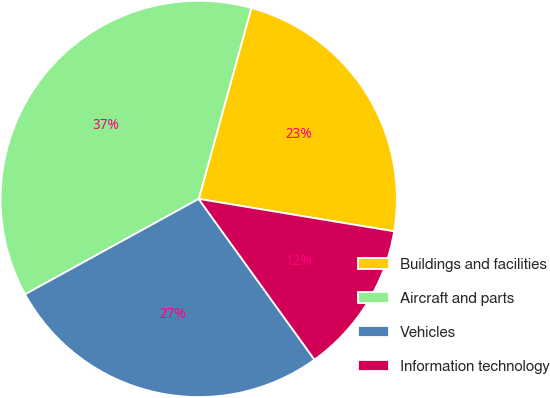Convert chart. <chart><loc_0><loc_0><loc_500><loc_500><pie_chart><fcel>Buildings and facilities<fcel>Aircraft and parts<fcel>Vehicles<fcel>Information technology<nl><fcel>23.34%<fcel>37.28%<fcel>26.94%<fcel>12.45%<nl></chart> 